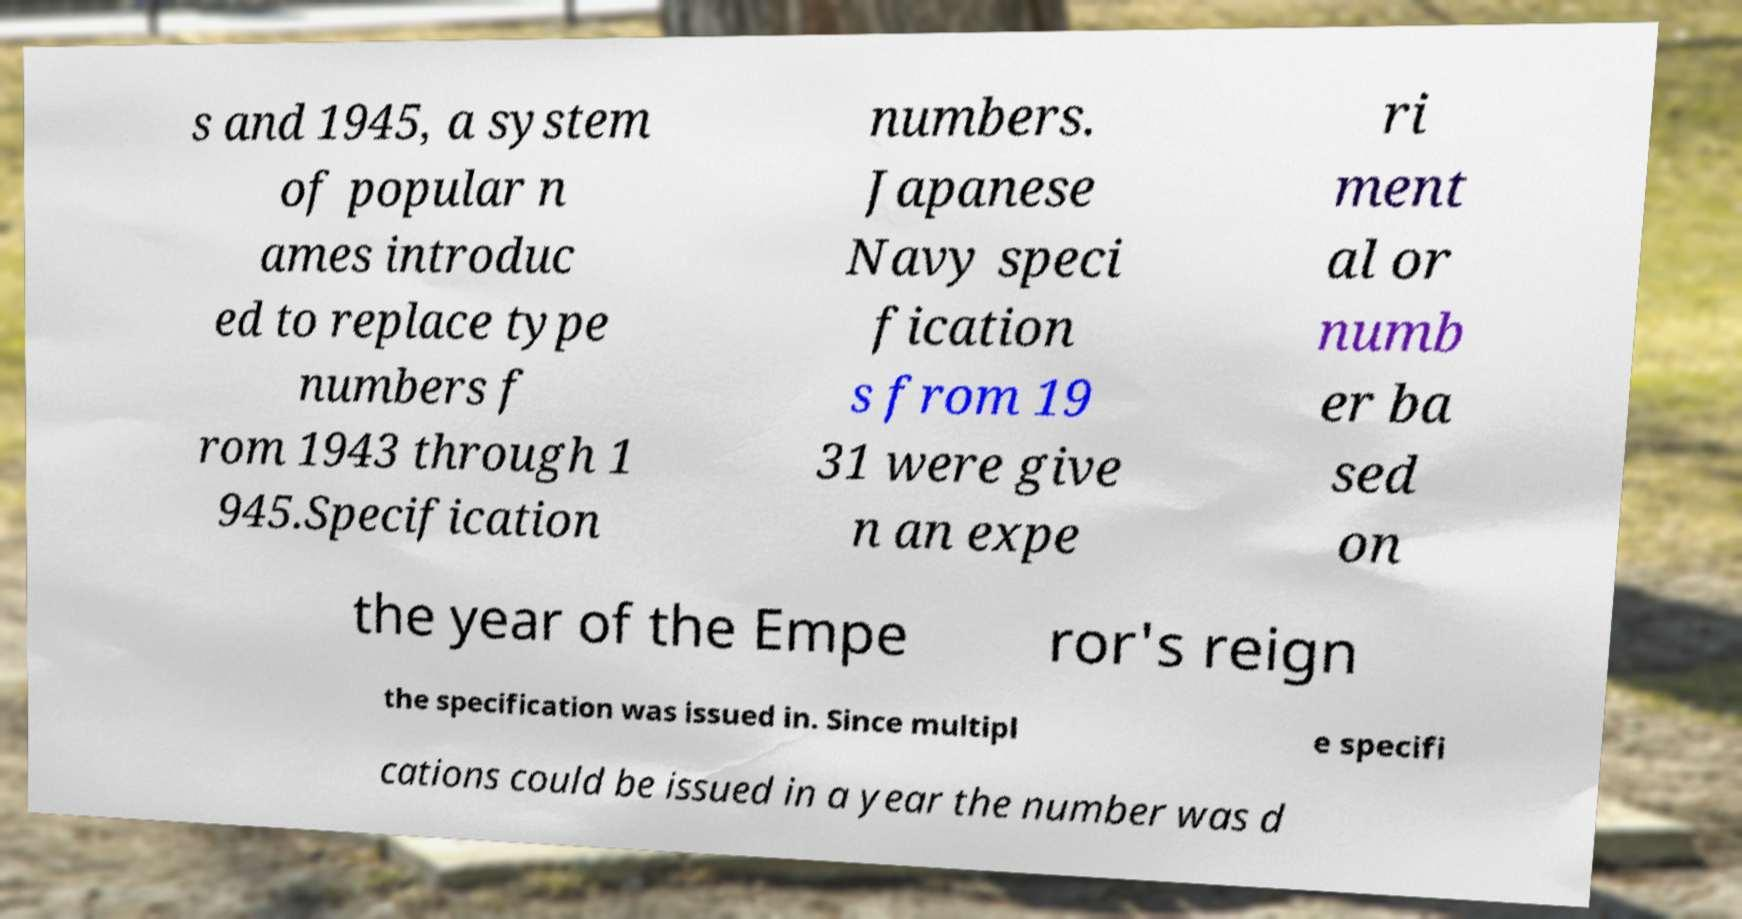For documentation purposes, I need the text within this image transcribed. Could you provide that? s and 1945, a system of popular n ames introduc ed to replace type numbers f rom 1943 through 1 945.Specification numbers. Japanese Navy speci fication s from 19 31 were give n an expe ri ment al or numb er ba sed on the year of the Empe ror's reign the specification was issued in. Since multipl e specifi cations could be issued in a year the number was d 